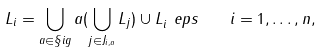Convert formula to latex. <formula><loc_0><loc_0><loc_500><loc_500>L _ { i } = \bigcup _ { a \in \S i g } a ( \bigcup _ { j \in J _ { i , a } } L _ { j } ) \cup L _ { i } ^ { \ } e p s \quad i = 1 , \dots , n ,</formula> 